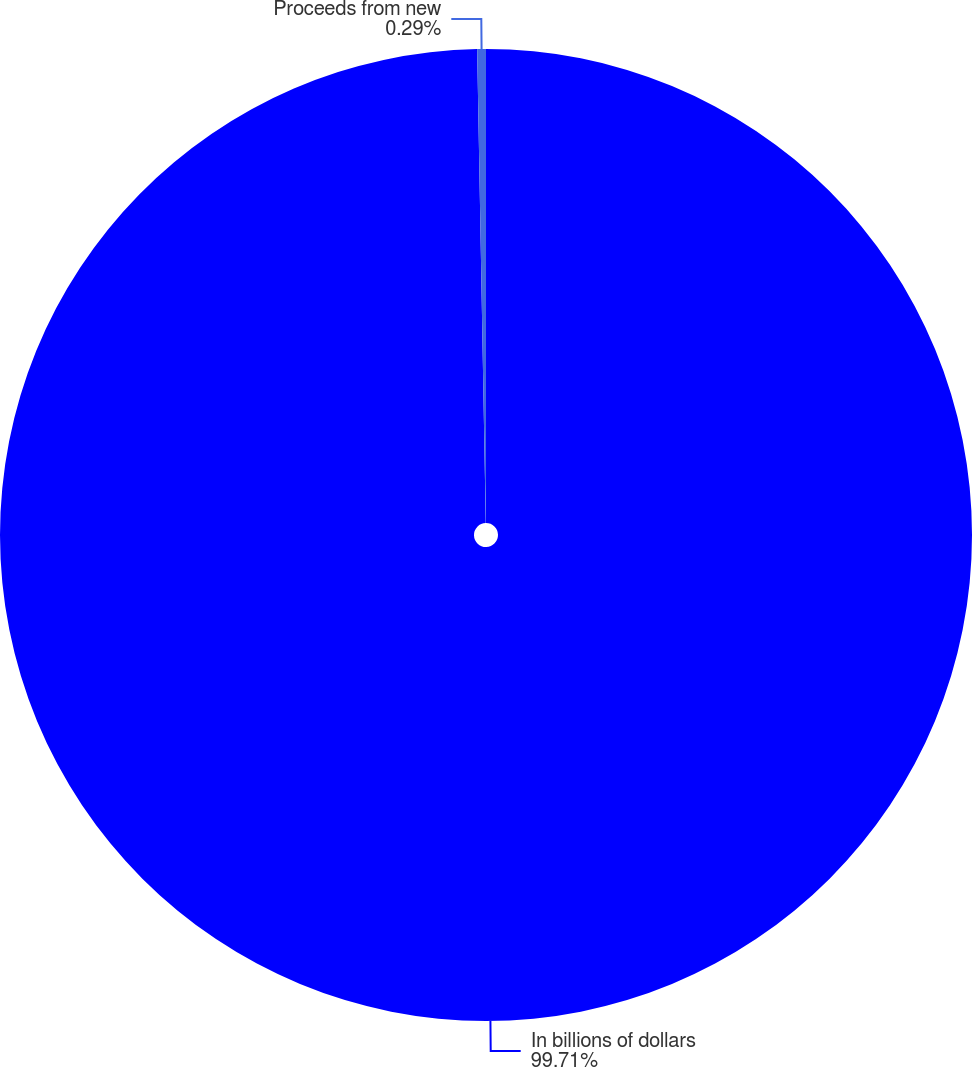<chart> <loc_0><loc_0><loc_500><loc_500><pie_chart><fcel>In billions of dollars<fcel>Proceeds from new<nl><fcel>99.71%<fcel>0.29%<nl></chart> 